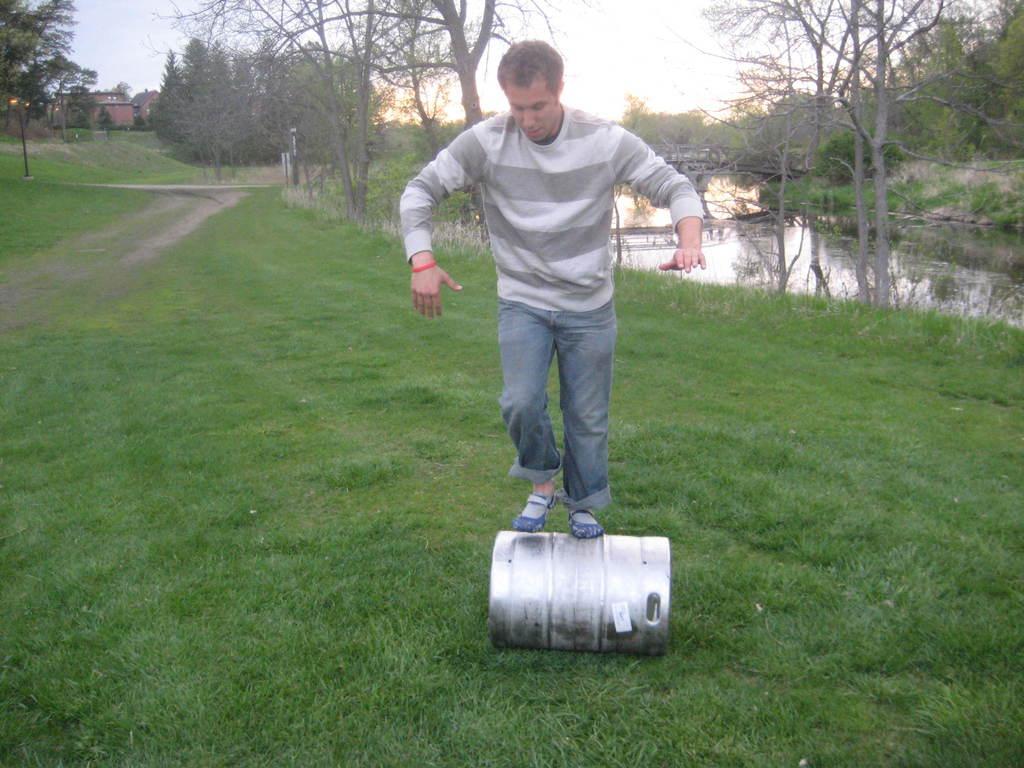Can you describe this image briefly? In the image there is a man standing on a metal roller on the land land, on the right side it seems to be a pond and trees on either side of it and above its sky. 